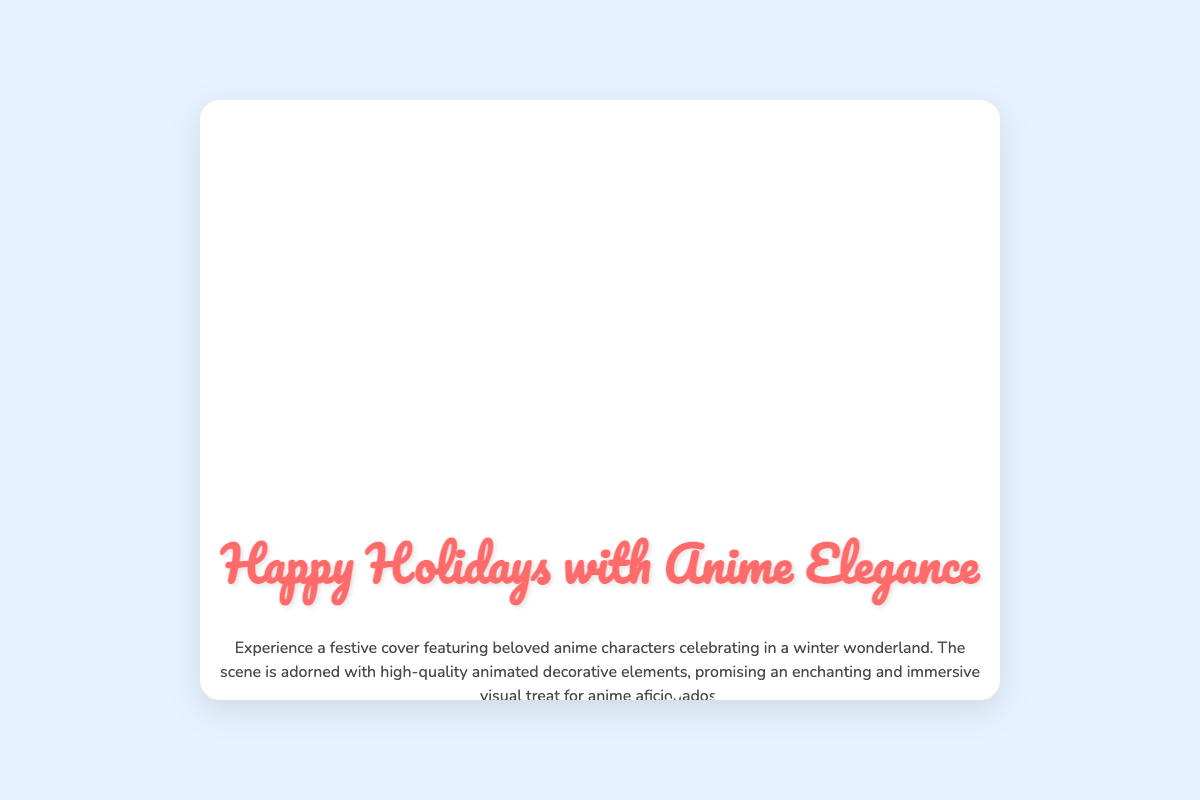What is the title of the greeting card? The title is prominently displayed at the top of the card's front cover.
Answer: Happy Holidays with Anime Elegance How many anime characters are featured on the front cover? The front cover includes three characters positioned in different locations.
Answer: Three What color is the background of the card? The background color can be described from the CSS style provided for the body of the card.
Answer: #e6f2ff What type of attire are the characters wearing inside the card? The inside message references character illustrations in a specific festive style.
Answer: Festive attire What wish is expressed inside the card? The inside message conveys a specific holiday sentiment, reflecting joy and vibrancy.
Answer: Warm Holiday Wishes How many scenes are illustrated inside the card? The inside of the card features a specific number of different scenes displayed in a flexible layout.
Answer: Three What is the main theme of the card's illustration? The visual elements are centered around a particular seasonal celebration that is characteristic of winter festivities.
Answer: Winter wonderland What is one element that enhances the card's festive look? There is a specific animated decorative element mentioned that contributes to the overall aesthetic.
Answer: Snowflakes 